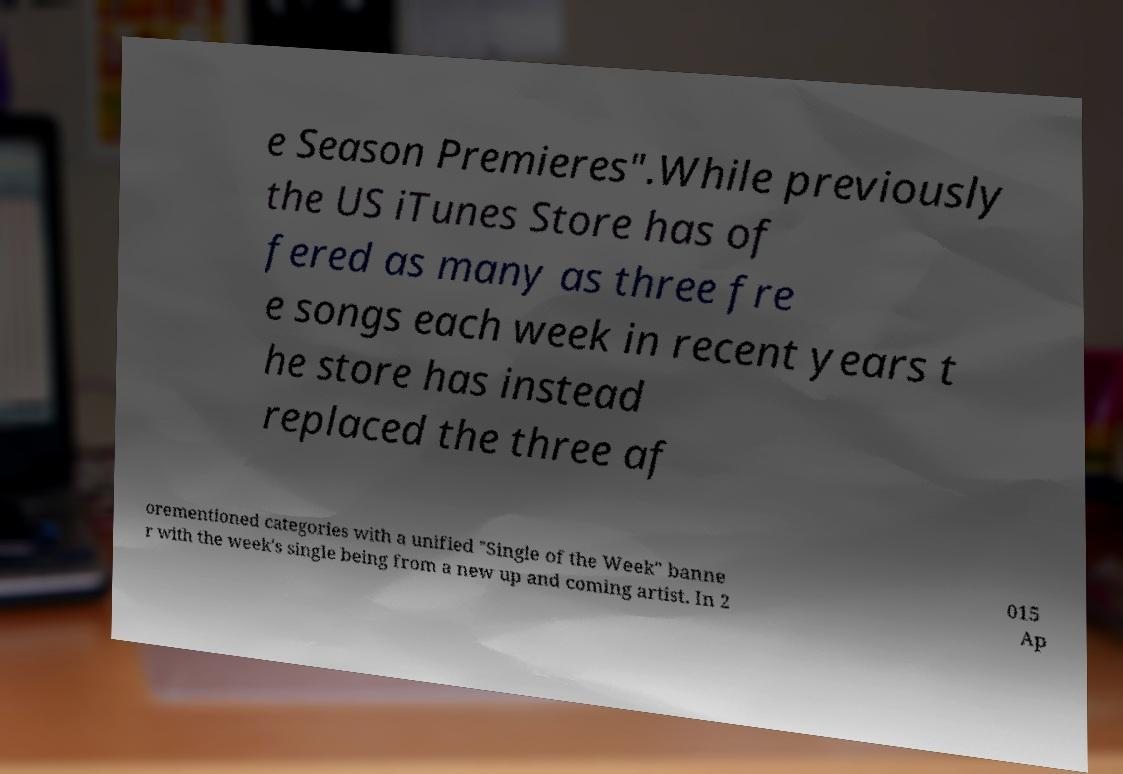What messages or text are displayed in this image? I need them in a readable, typed format. e Season Premieres".While previously the US iTunes Store has of fered as many as three fre e songs each week in recent years t he store has instead replaced the three af orementioned categories with a unified "Single of the Week" banne r with the week's single being from a new up and coming artist. In 2 015 Ap 